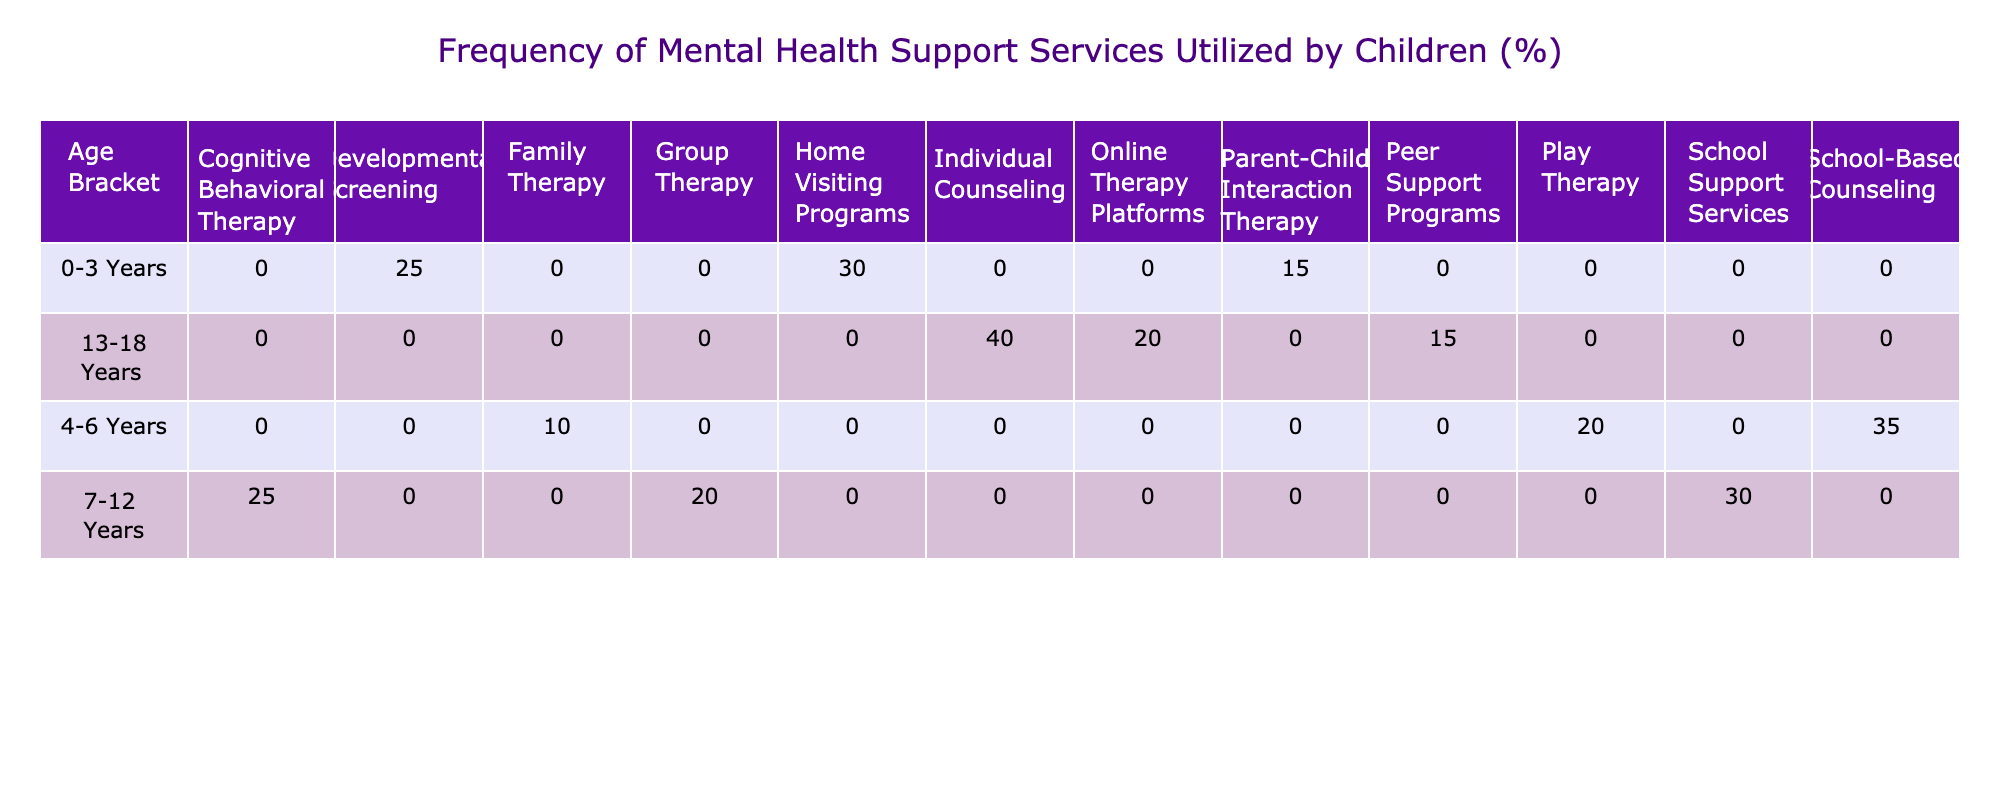What is the frequency of Home Visiting Programs for children aged 0-3 years? According to the table, Home Visiting Programs have a frequency of 30% for children in the 0-3 years age bracket.
Answer: 30% Which mental health support service has the highest utilization among children aged 13-18 years? In the age bracket 13-18 years, Individual Counseling has the highest frequency utilized at 40%.
Answer: Individual Counseling What percentage of children aged 4-6 years utilize either Play Therapy or School-Based Counseling? Play Therapy is utilized by 20%, and School-Based Counseling is utilized by 35%. Adding these together gives 20 + 35 = 55%.
Answer: 55% Is the percentage of Group Therapy utilized by 7-12 years old children greater than the percentage of Family Therapy utilized by 4-6 years old children? The percentage of Group Therapy for the 7-12 years age group is 20%, while Family Therapy for the 4-6 years age group is 10%. Since 20% is greater than 10%, the statement is true.
Answer: Yes What is the total percentage of mental health support services utilized by children aged 0-3 years? The frequencies for this age bracket are: Parent-Child Interaction Therapy (15%), Developmental Screening (25%), and Home Visiting Programs (30%). Adding them gives a total of 15 + 25 + 30 = 70%.
Answer: 70% 